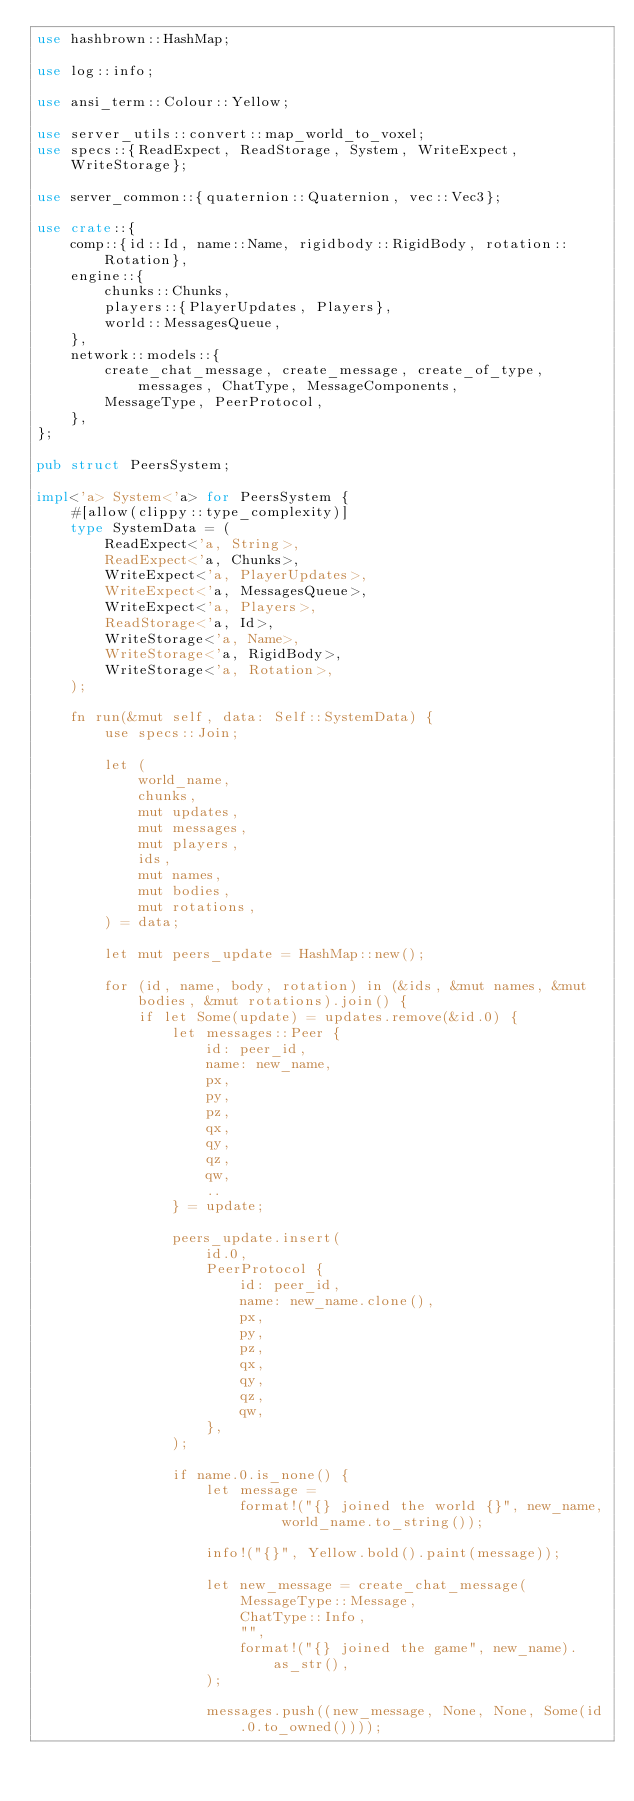Convert code to text. <code><loc_0><loc_0><loc_500><loc_500><_Rust_>use hashbrown::HashMap;

use log::info;

use ansi_term::Colour::Yellow;

use server_utils::convert::map_world_to_voxel;
use specs::{ReadExpect, ReadStorage, System, WriteExpect, WriteStorage};

use server_common::{quaternion::Quaternion, vec::Vec3};

use crate::{
    comp::{id::Id, name::Name, rigidbody::RigidBody, rotation::Rotation},
    engine::{
        chunks::Chunks,
        players::{PlayerUpdates, Players},
        world::MessagesQueue,
    },
    network::models::{
        create_chat_message, create_message, create_of_type, messages, ChatType, MessageComponents,
        MessageType, PeerProtocol,
    },
};

pub struct PeersSystem;

impl<'a> System<'a> for PeersSystem {
    #[allow(clippy::type_complexity)]
    type SystemData = (
        ReadExpect<'a, String>,
        ReadExpect<'a, Chunks>,
        WriteExpect<'a, PlayerUpdates>,
        WriteExpect<'a, MessagesQueue>,
        WriteExpect<'a, Players>,
        ReadStorage<'a, Id>,
        WriteStorage<'a, Name>,
        WriteStorage<'a, RigidBody>,
        WriteStorage<'a, Rotation>,
    );

    fn run(&mut self, data: Self::SystemData) {
        use specs::Join;

        let (
            world_name,
            chunks,
            mut updates,
            mut messages,
            mut players,
            ids,
            mut names,
            mut bodies,
            mut rotations,
        ) = data;

        let mut peers_update = HashMap::new();

        for (id, name, body, rotation) in (&ids, &mut names, &mut bodies, &mut rotations).join() {
            if let Some(update) = updates.remove(&id.0) {
                let messages::Peer {
                    id: peer_id,
                    name: new_name,
                    px,
                    py,
                    pz,
                    qx,
                    qy,
                    qz,
                    qw,
                    ..
                } = update;

                peers_update.insert(
                    id.0,
                    PeerProtocol {
                        id: peer_id,
                        name: new_name.clone(),
                        px,
                        py,
                        pz,
                        qx,
                        qy,
                        qz,
                        qw,
                    },
                );

                if name.0.is_none() {
                    let message =
                        format!("{} joined the world {}", new_name, world_name.to_string());

                    info!("{}", Yellow.bold().paint(message));

                    let new_message = create_chat_message(
                        MessageType::Message,
                        ChatType::Info,
                        "",
                        format!("{} joined the game", new_name).as_str(),
                    );

                    messages.push((new_message, None, None, Some(id.0.to_owned())));</code> 